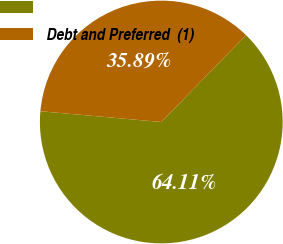<chart> <loc_0><loc_0><loc_500><loc_500><pie_chart><ecel><fcel>Debt and Preferred  (1)<nl><fcel>64.11%<fcel>35.89%<nl></chart> 